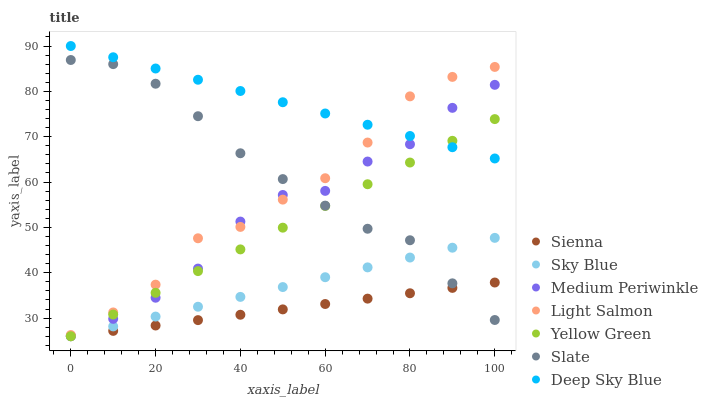Does Sienna have the minimum area under the curve?
Answer yes or no. Yes. Does Deep Sky Blue have the maximum area under the curve?
Answer yes or no. Yes. Does Yellow Green have the minimum area under the curve?
Answer yes or no. No. Does Yellow Green have the maximum area under the curve?
Answer yes or no. No. Is Sienna the smoothest?
Answer yes or no. Yes. Is Medium Periwinkle the roughest?
Answer yes or no. Yes. Is Yellow Green the smoothest?
Answer yes or no. No. Is Yellow Green the roughest?
Answer yes or no. No. Does Yellow Green have the lowest value?
Answer yes or no. Yes. Does Slate have the lowest value?
Answer yes or no. No. Does Deep Sky Blue have the highest value?
Answer yes or no. Yes. Does Yellow Green have the highest value?
Answer yes or no. No. Is Sienna less than Medium Periwinkle?
Answer yes or no. Yes. Is Light Salmon greater than Sienna?
Answer yes or no. Yes. Does Deep Sky Blue intersect Yellow Green?
Answer yes or no. Yes. Is Deep Sky Blue less than Yellow Green?
Answer yes or no. No. Is Deep Sky Blue greater than Yellow Green?
Answer yes or no. No. Does Sienna intersect Medium Periwinkle?
Answer yes or no. No. 